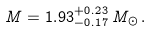Convert formula to latex. <formula><loc_0><loc_0><loc_500><loc_500>M = 1 . 9 3 ^ { + 0 . 2 3 } _ { - 0 . 1 7 } \, M _ { \odot } \, .</formula> 